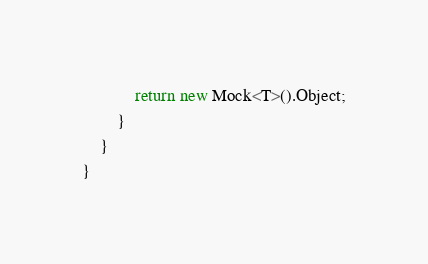Convert code to text. <code><loc_0><loc_0><loc_500><loc_500><_C#_>            return new Mock<T>().Object;
        }
    }
}</code> 